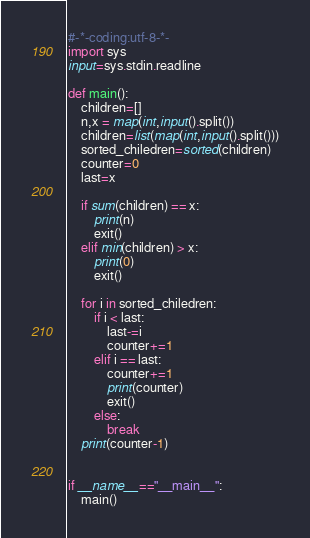Convert code to text. <code><loc_0><loc_0><loc_500><loc_500><_Python_>#-*-coding:utf-8-*-
import sys
input=sys.stdin.readline

def main():
    children=[]
    n,x = map(int,input().split())
    children=list(map(int,input().split()))
    sorted_chiledren=sorted(children)
    counter=0
    last=x

    if sum(children) == x:
        print(n)
        exit()
    elif min(children) > x:
        print(0)
        exit()

    for i in sorted_chiledren:
        if i < last:
            last-=i
            counter+=1
        elif i == last:
            counter+=1
            print(counter)
            exit()
        else:
            break
    print(counter-1)

    
if __name__=="__main__":
    main()</code> 